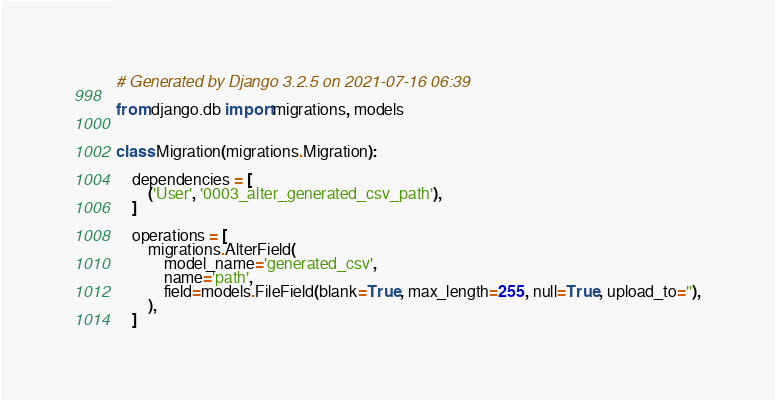Convert code to text. <code><loc_0><loc_0><loc_500><loc_500><_Python_># Generated by Django 3.2.5 on 2021-07-16 06:39

from django.db import migrations, models


class Migration(migrations.Migration):

    dependencies = [
        ('User', '0003_alter_generated_csv_path'),
    ]

    operations = [
        migrations.AlterField(
            model_name='generated_csv',
            name='path',
            field=models.FileField(blank=True, max_length=255, null=True, upload_to=''),
        ),
    ]
</code> 